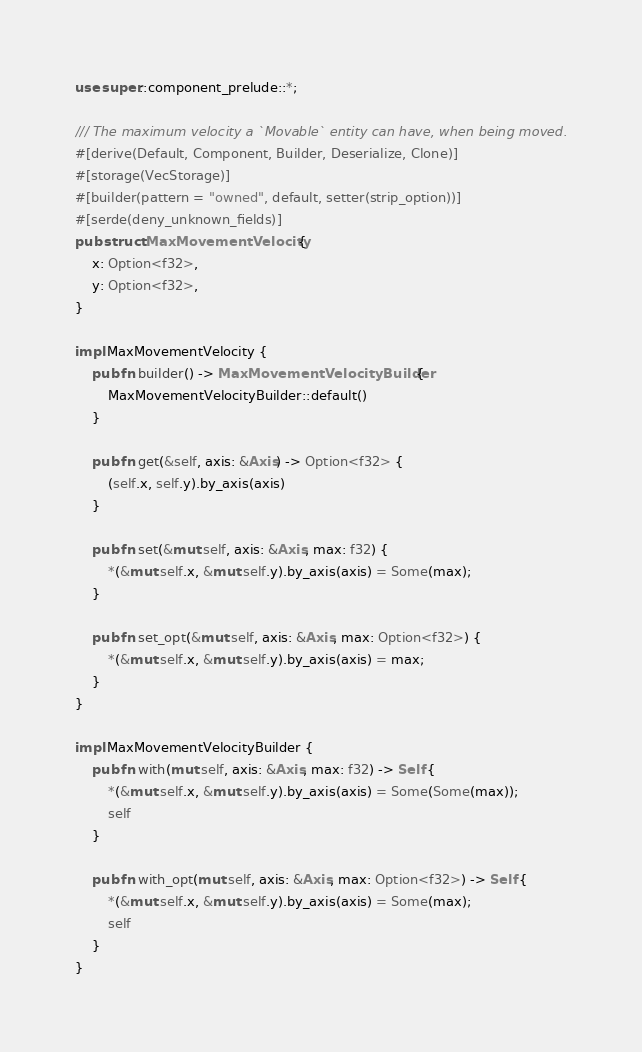Convert code to text. <code><loc_0><loc_0><loc_500><loc_500><_Rust_>use super::component_prelude::*;

/// The maximum velocity a `Movable` entity can have, when being moved.
#[derive(Default, Component, Builder, Deserialize, Clone)]
#[storage(VecStorage)]
#[builder(pattern = "owned", default, setter(strip_option))]
#[serde(deny_unknown_fields)]
pub struct MaxMovementVelocity {
    x: Option<f32>,
    y: Option<f32>,
}

impl MaxMovementVelocity {
    pub fn builder() -> MaxMovementVelocityBuilder {
        MaxMovementVelocityBuilder::default()
    }

    pub fn get(&self, axis: &Axis) -> Option<f32> {
        (self.x, self.y).by_axis(axis)
    }

    pub fn set(&mut self, axis: &Axis, max: f32) {
        *(&mut self.x, &mut self.y).by_axis(axis) = Some(max);
    }

    pub fn set_opt(&mut self, axis: &Axis, max: Option<f32>) {
        *(&mut self.x, &mut self.y).by_axis(axis) = max;
    }
}

impl MaxMovementVelocityBuilder {
    pub fn with(mut self, axis: &Axis, max: f32) -> Self {
        *(&mut self.x, &mut self.y).by_axis(axis) = Some(Some(max));
        self
    }

    pub fn with_opt(mut self, axis: &Axis, max: Option<f32>) -> Self {
        *(&mut self.x, &mut self.y).by_axis(axis) = Some(max);
        self
    }
}
</code> 